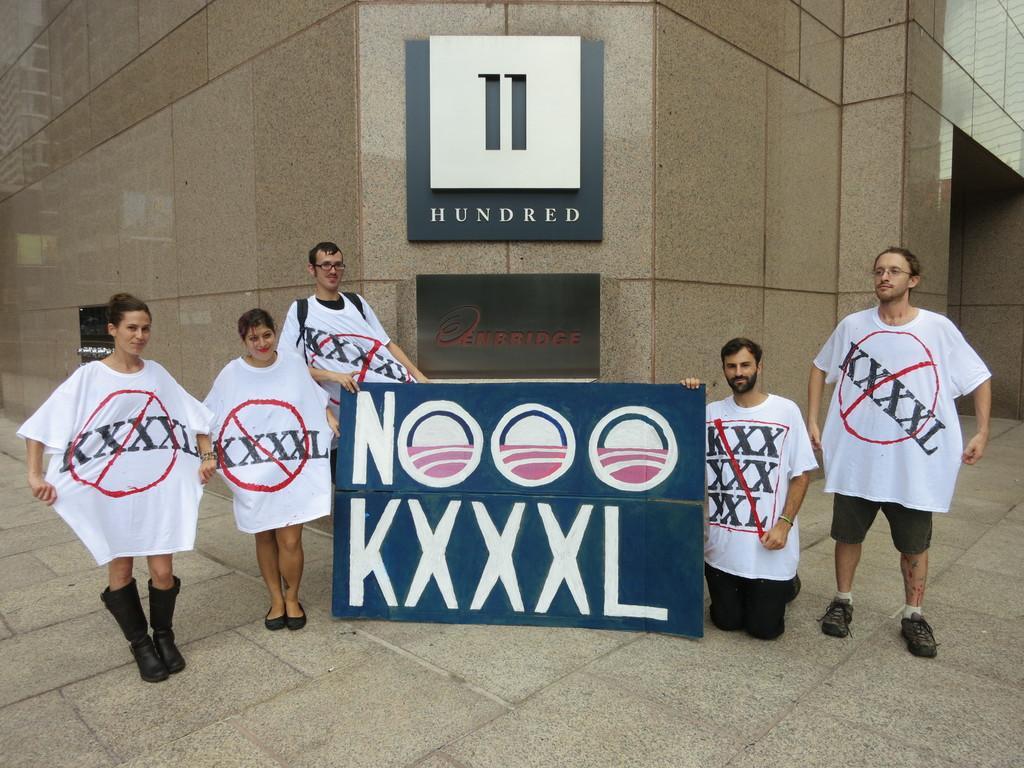Please provide a concise description of this image. In this image I can see few people standing and few are holding blue color board. They are wearing white and black color dresses. Back I can see a building and boards are attached to the wall. 